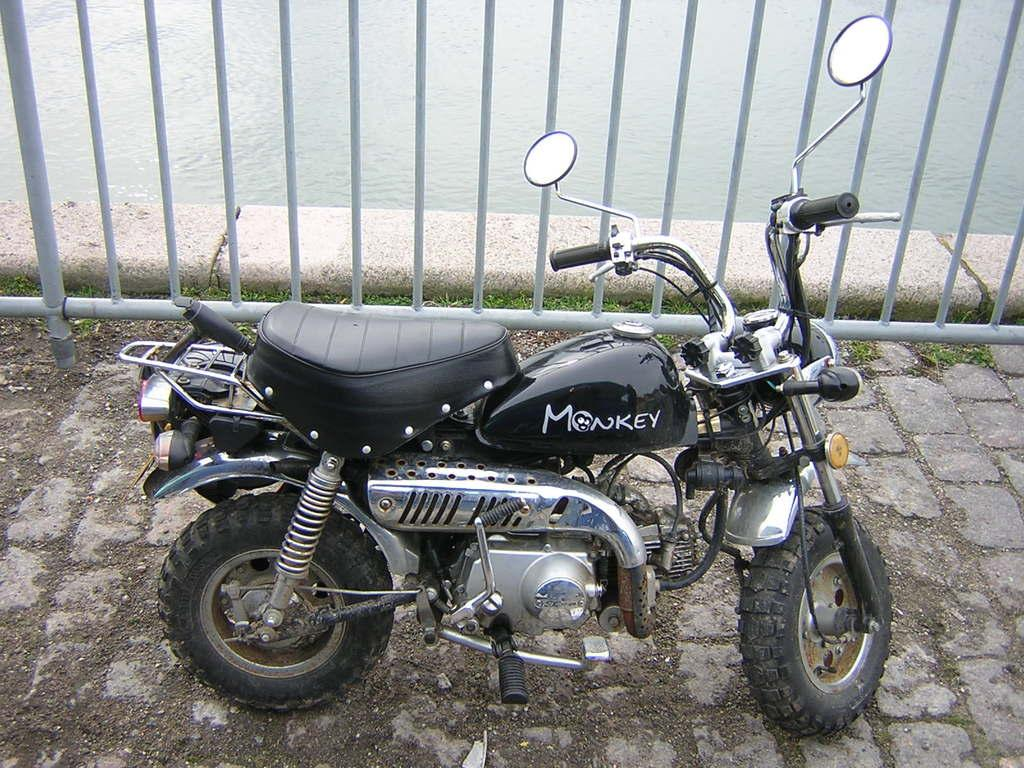What is the main subject of the image? The main subject of the image is a motorbike. Can you describe the motorbike's position in the image? The motorbike is on a surface in the image. What is located behind the motorbike? There is a fencing behind the motorbike. What else can be seen in the image besides the motorbike? Water is visible in the image. How many rabbits can be seen playing with a plough in the image? There are no rabbits or ploughs present in the image; it features a motorbike on a surface with a fencing and water visible. 